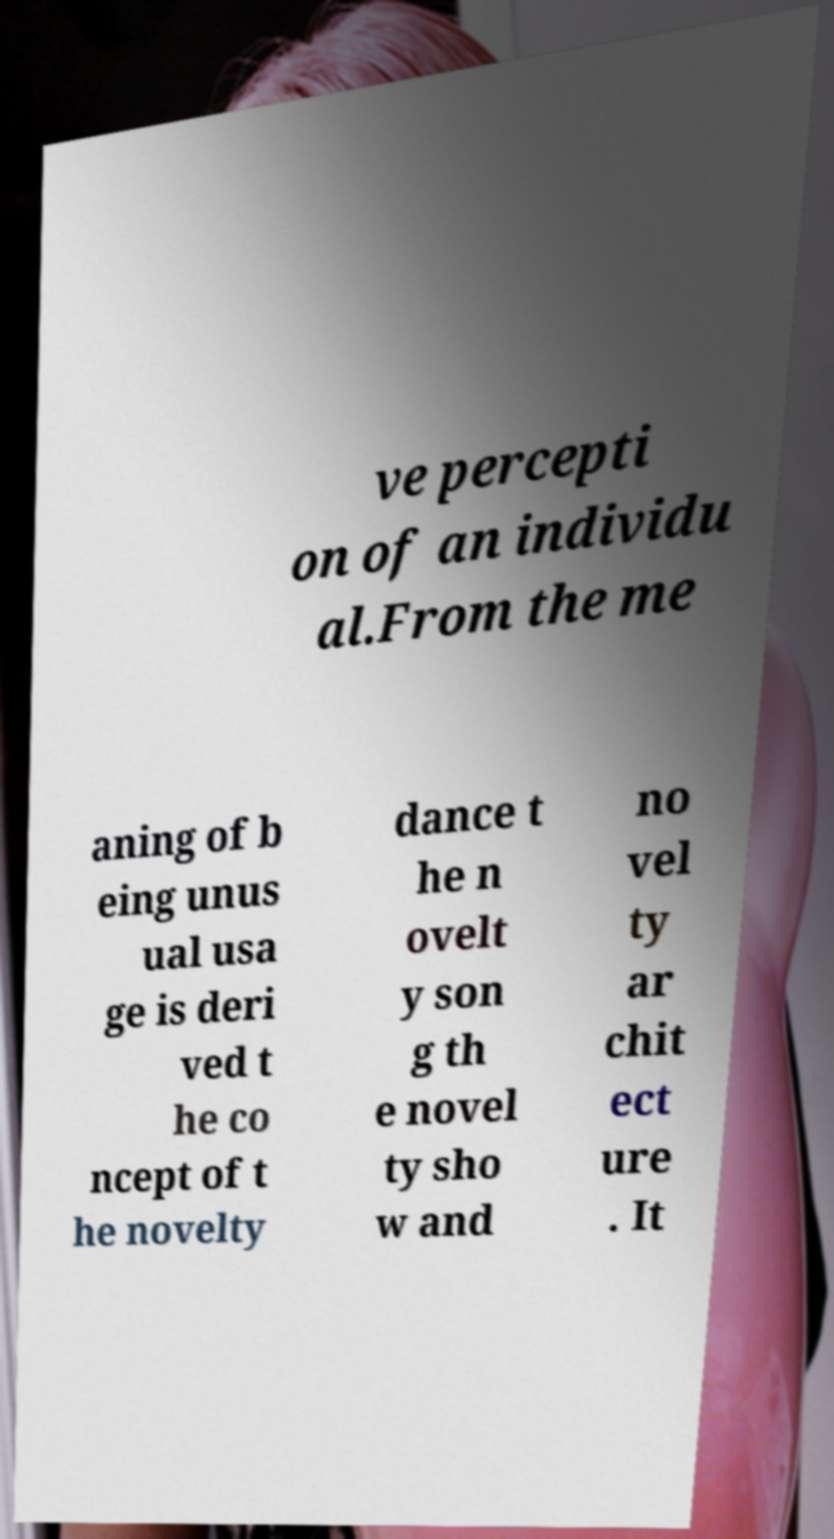Please identify and transcribe the text found in this image. ve percepti on of an individu al.From the me aning of b eing unus ual usa ge is deri ved t he co ncept of t he novelty dance t he n ovelt y son g th e novel ty sho w and no vel ty ar chit ect ure . It 